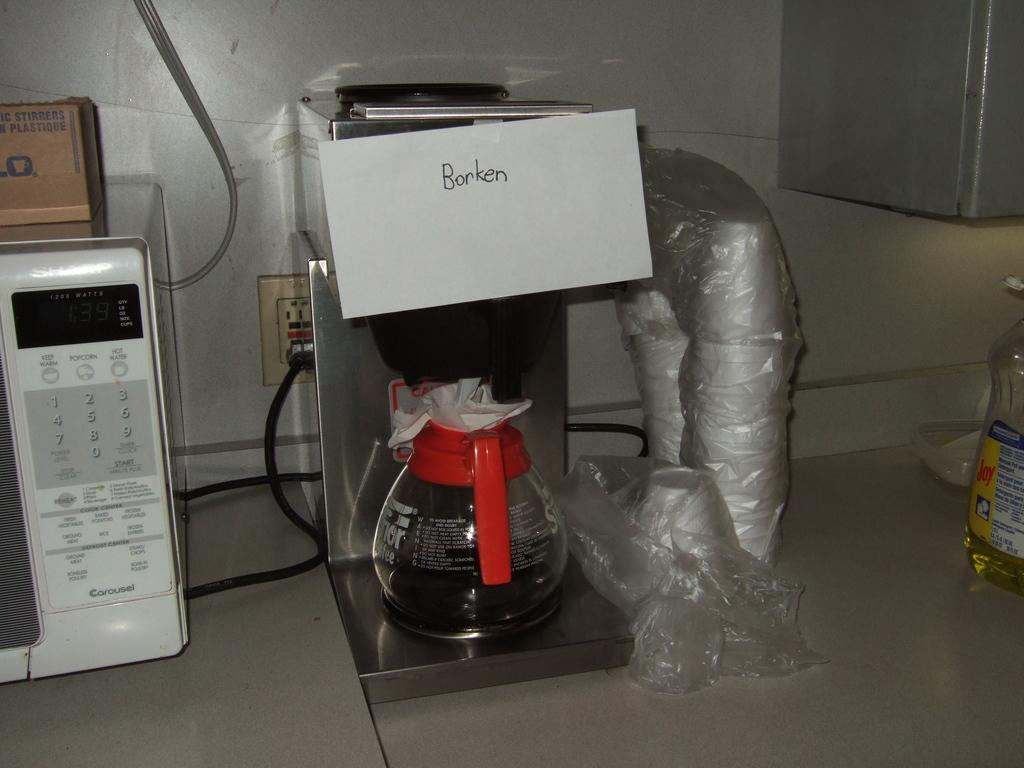Provide a one-sentence caption for the provided image. A coffee maker with the word Borken pinned on it. 